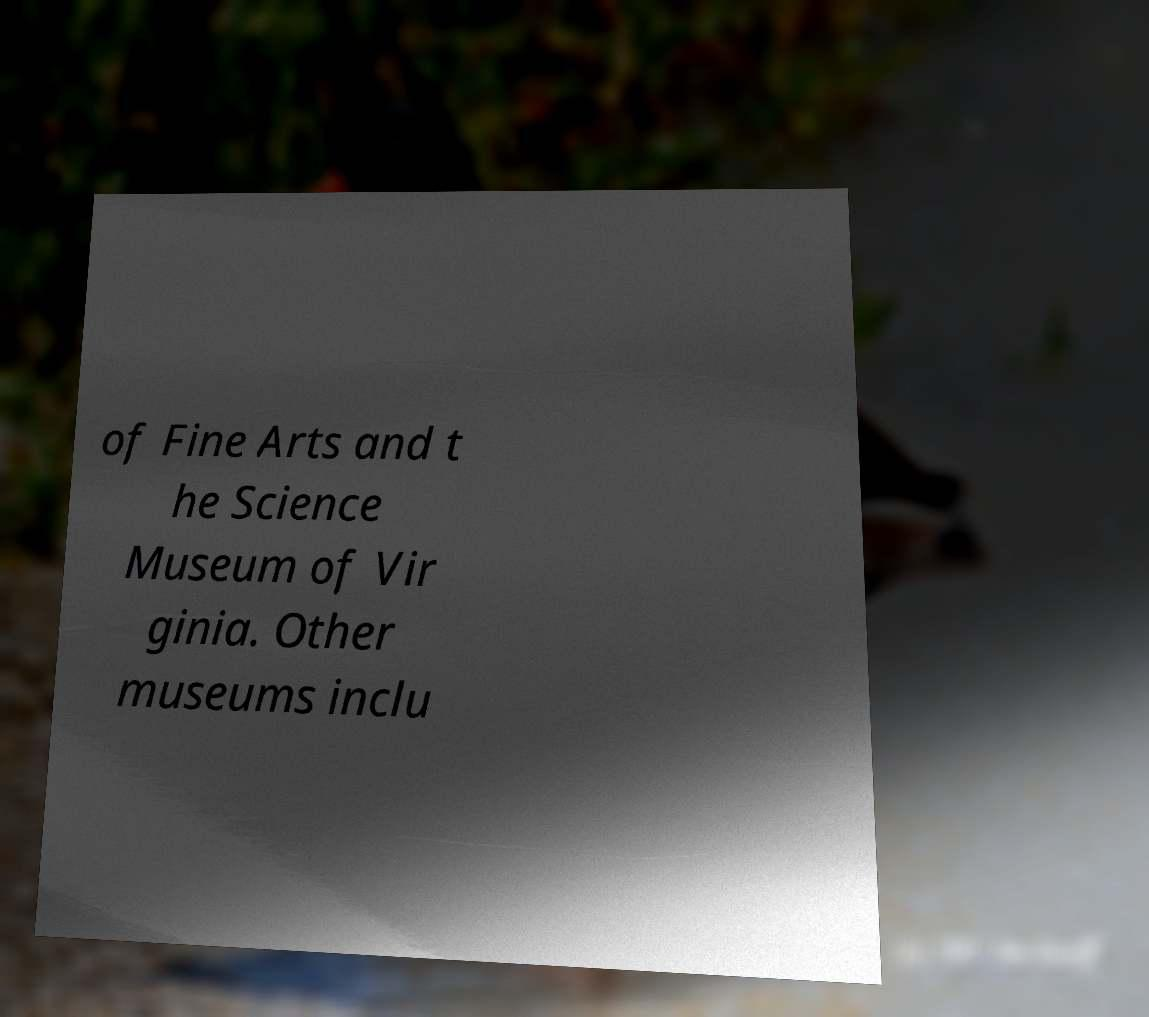Please read and relay the text visible in this image. What does it say? of Fine Arts and t he Science Museum of Vir ginia. Other museums inclu 